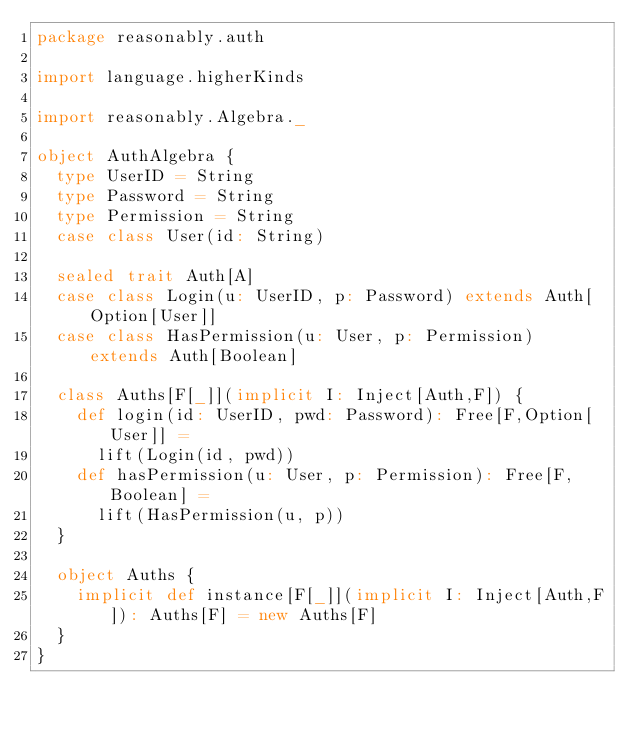<code> <loc_0><loc_0><loc_500><loc_500><_Scala_>package reasonably.auth

import language.higherKinds

import reasonably.Algebra._

object AuthAlgebra {
  type UserID = String
  type Password = String
  type Permission = String
  case class User(id: String)

  sealed trait Auth[A]
  case class Login(u: UserID, p: Password) extends Auth[Option[User]]
  case class HasPermission(u: User, p: Permission) extends Auth[Boolean]

  class Auths[F[_]](implicit I: Inject[Auth,F]) {
    def login(id: UserID, pwd: Password): Free[F,Option[User]] =
      lift(Login(id, pwd))
    def hasPermission(u: User, p: Permission): Free[F,Boolean] =
      lift(HasPermission(u, p))
  }

  object Auths {
    implicit def instance[F[_]](implicit I: Inject[Auth,F]): Auths[F] = new Auths[F]
  }
}

</code> 